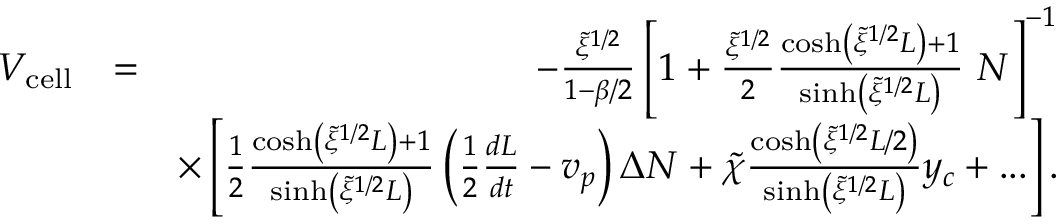<formula> <loc_0><loc_0><loc_500><loc_500>\begin{array} { r l r } { V _ { c e l l } } & { = } & { - \frac { \tilde { \xi } ^ { 1 / 2 } } { 1 - \beta / 2 } \left [ 1 + \frac { \tilde { \xi } ^ { 1 / 2 } } { 2 } \frac { \cosh \left ( \tilde { \xi } ^ { 1 / 2 } L \right ) + 1 } { \sinh \left ( \tilde { \xi } ^ { 1 / 2 } L \right ) } \ N \right ] ^ { - 1 } } \\ & { \times \left [ \frac { 1 } { 2 } \frac { \cosh \left ( \tilde { \xi } ^ { 1 / 2 } L \right ) + 1 } { \sinh \left ( \tilde { \xi } ^ { 1 / 2 } L \right ) } \left ( \frac { 1 } { 2 } \frac { d L } { d t } - v _ { p } \right ) \Delta N + \tilde { \chi } \frac { \cosh \left ( \tilde { \xi } ^ { 1 / 2 } L / 2 \right ) } { \sinh \left ( \tilde { \xi } ^ { 1 / 2 } L \right ) } y _ { c } + \dots \right ] . } \end{array}</formula> 